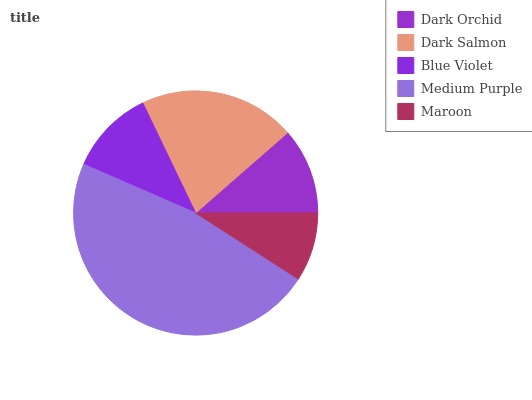Is Maroon the minimum?
Answer yes or no. Yes. Is Medium Purple the maximum?
Answer yes or no. Yes. Is Dark Salmon the minimum?
Answer yes or no. No. Is Dark Salmon the maximum?
Answer yes or no. No. Is Dark Salmon greater than Dark Orchid?
Answer yes or no. Yes. Is Dark Orchid less than Dark Salmon?
Answer yes or no. Yes. Is Dark Orchid greater than Dark Salmon?
Answer yes or no. No. Is Dark Salmon less than Dark Orchid?
Answer yes or no. No. Is Dark Orchid the high median?
Answer yes or no. Yes. Is Dark Orchid the low median?
Answer yes or no. Yes. Is Medium Purple the high median?
Answer yes or no. No. Is Blue Violet the low median?
Answer yes or no. No. 